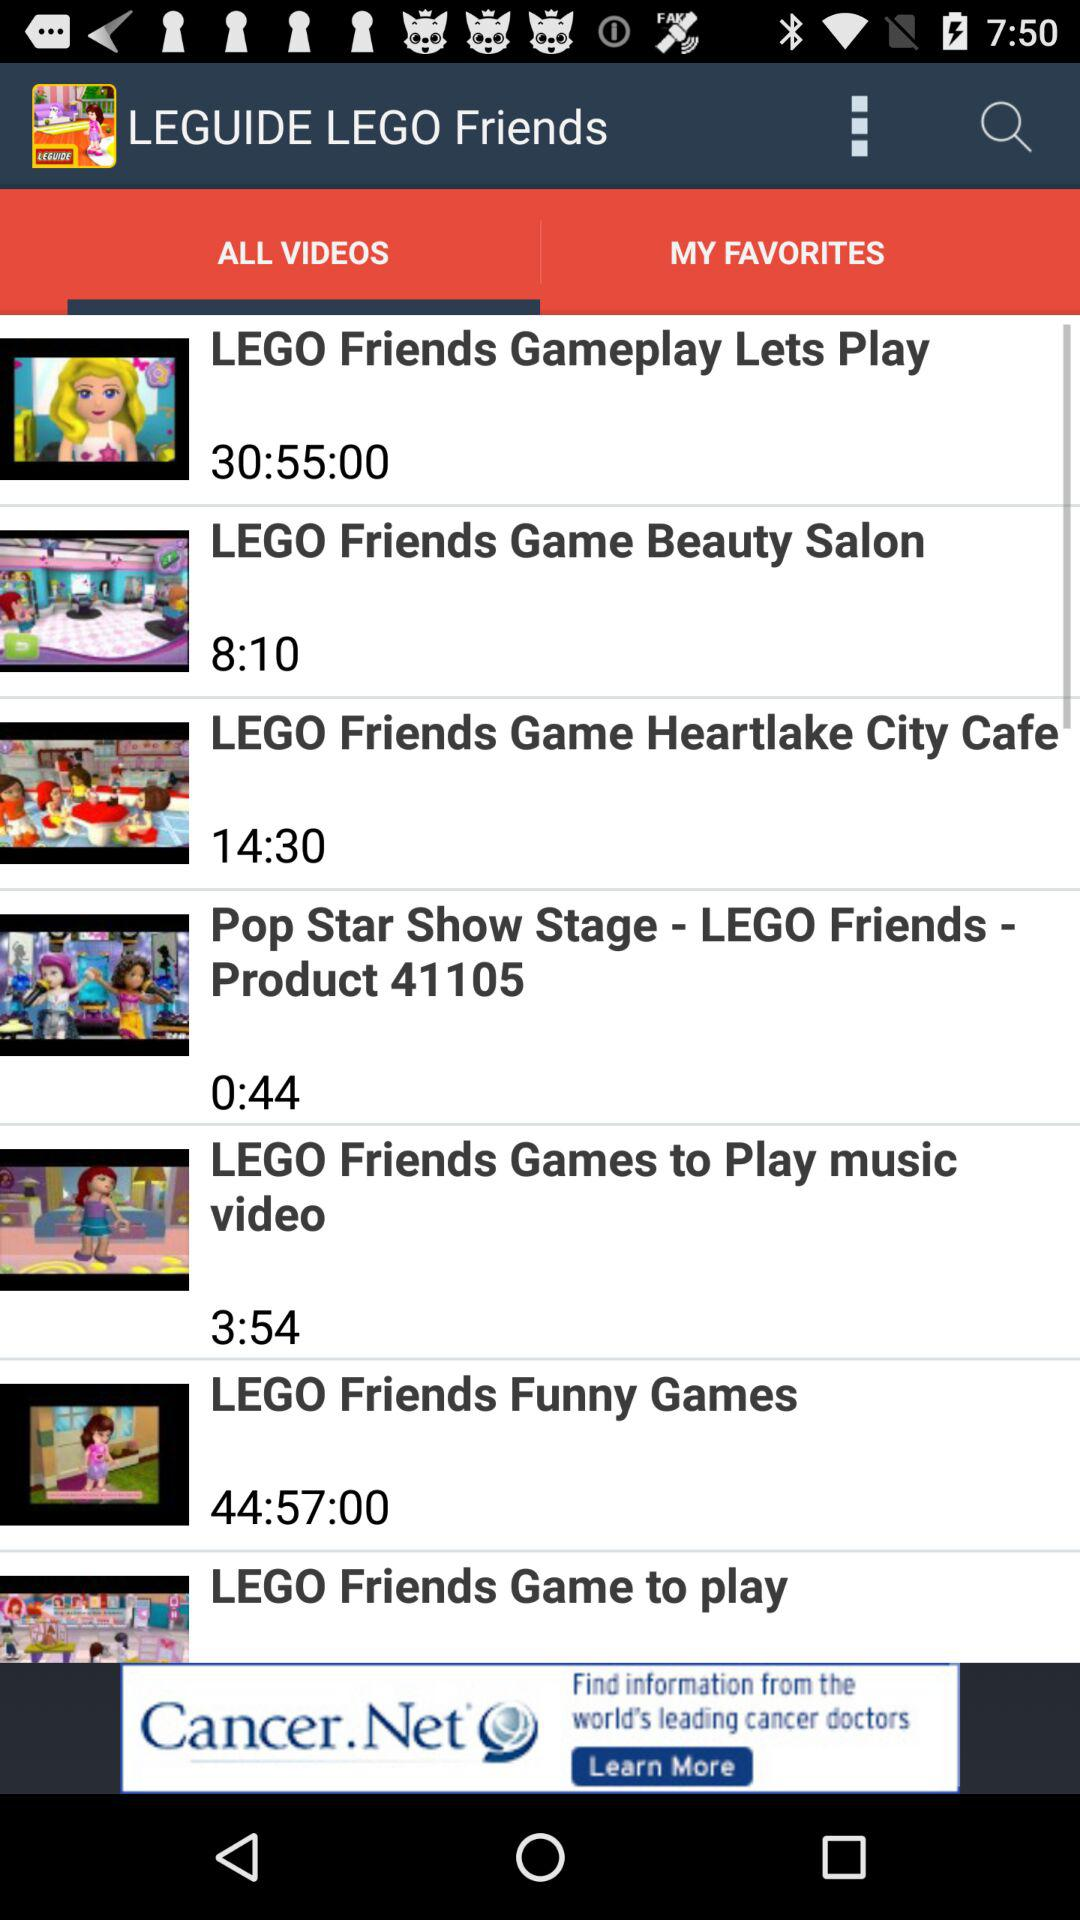What is the duration of the "LEGO Friends Gameplay Lets Play" video? The duration is 30 hours 55 minutes. 